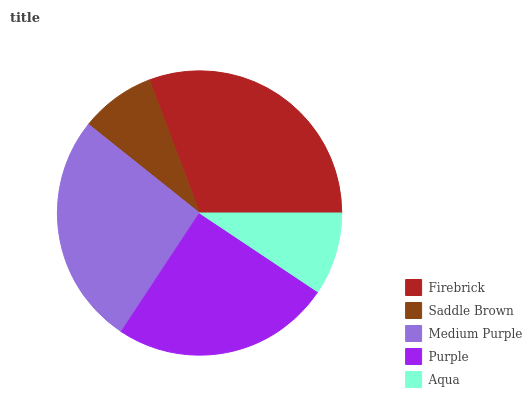Is Saddle Brown the minimum?
Answer yes or no. Yes. Is Firebrick the maximum?
Answer yes or no. Yes. Is Medium Purple the minimum?
Answer yes or no. No. Is Medium Purple the maximum?
Answer yes or no. No. Is Medium Purple greater than Saddle Brown?
Answer yes or no. Yes. Is Saddle Brown less than Medium Purple?
Answer yes or no. Yes. Is Saddle Brown greater than Medium Purple?
Answer yes or no. No. Is Medium Purple less than Saddle Brown?
Answer yes or no. No. Is Purple the high median?
Answer yes or no. Yes. Is Purple the low median?
Answer yes or no. Yes. Is Firebrick the high median?
Answer yes or no. No. Is Aqua the low median?
Answer yes or no. No. 